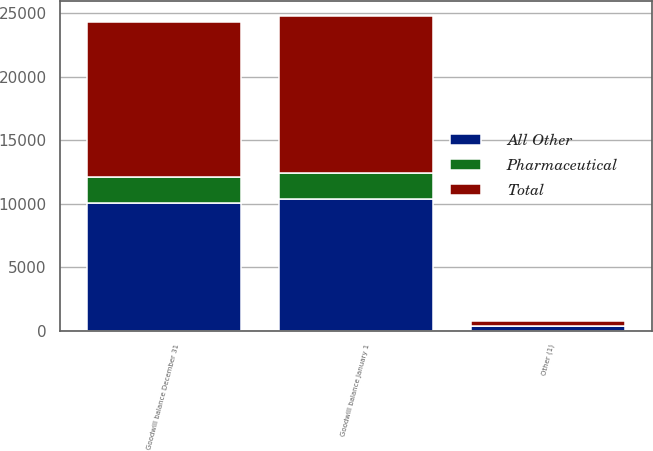<chart> <loc_0><loc_0><loc_500><loc_500><stacked_bar_chart><ecel><fcel>Goodwill balance January 1<fcel>Other (1)<fcel>Goodwill balance December 31<nl><fcel>All Other<fcel>10345<fcel>382<fcel>10086<nl><fcel>Pharmaceutical<fcel>2033<fcel>15<fcel>2048<nl><fcel>Total<fcel>12378<fcel>367<fcel>12134<nl></chart> 